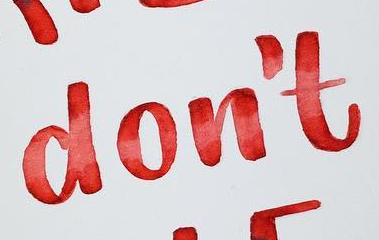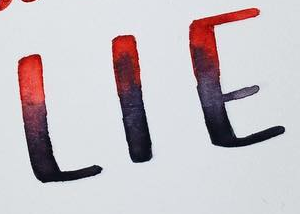What text is displayed in these images sequentially, separated by a semicolon? don't; LIE 